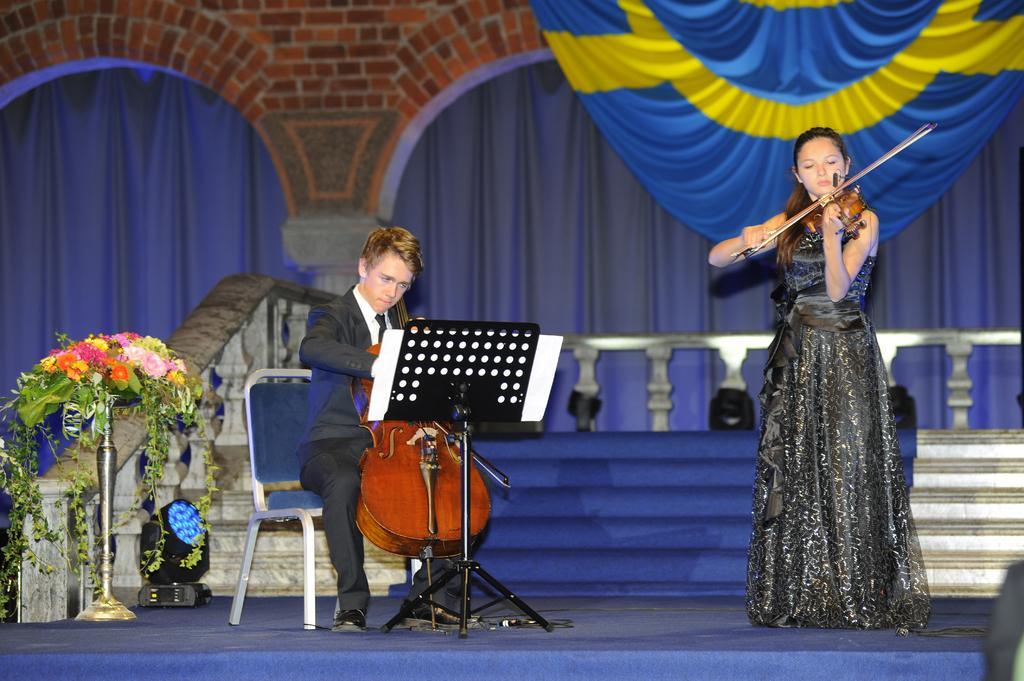In one or two sentences, can you explain what this image depicts? The girl in the black dress is holding a violin in her hands and she is playing it. She is standing on the stage. Beside her, the boy in white shirt and black blazer is sitting on the chair. He is holding a violin in his hand. I think he is playing the violin. Beside him, we see a flower vase. Behind them, we see a staircase and a blue color sheet. Behind that, we see stair railing. In the background, we see a wall which is made up of bricks. Beside that, we see a blue color sheet. In the right top of the picture, we see a sheet in blue and yellow color. 